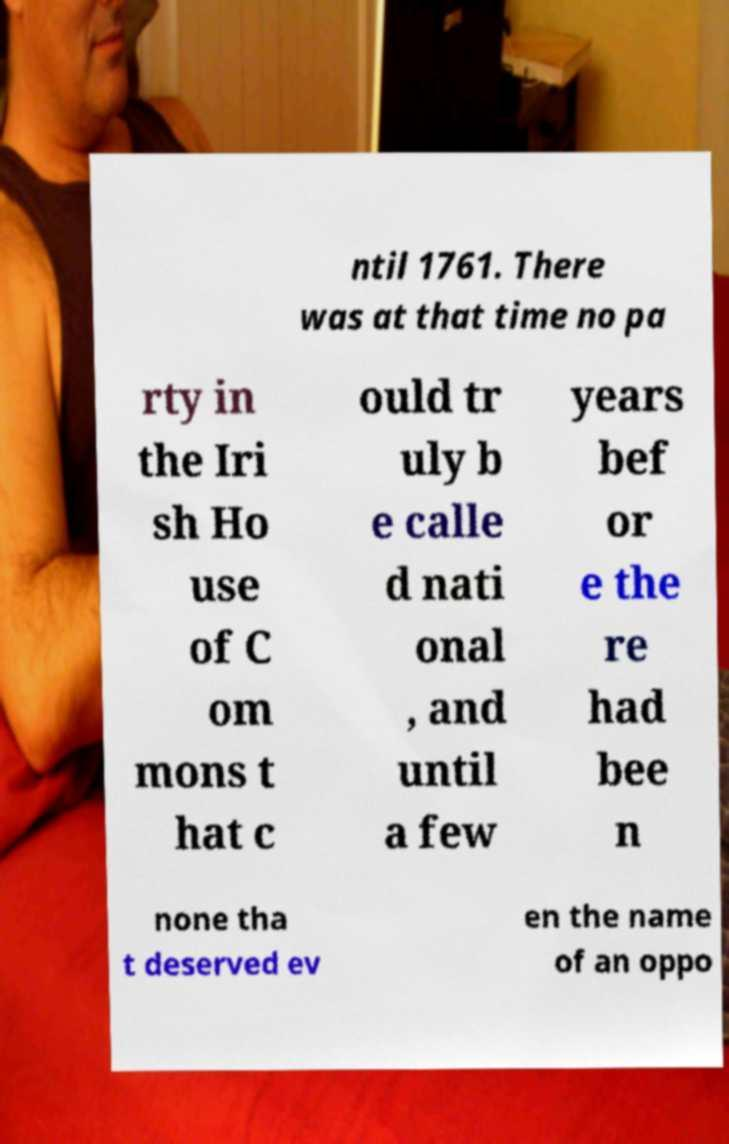Can you accurately transcribe the text from the provided image for me? ntil 1761. There was at that time no pa rty in the Iri sh Ho use of C om mons t hat c ould tr uly b e calle d nati onal , and until a few years bef or e the re had bee n none tha t deserved ev en the name of an oppo 